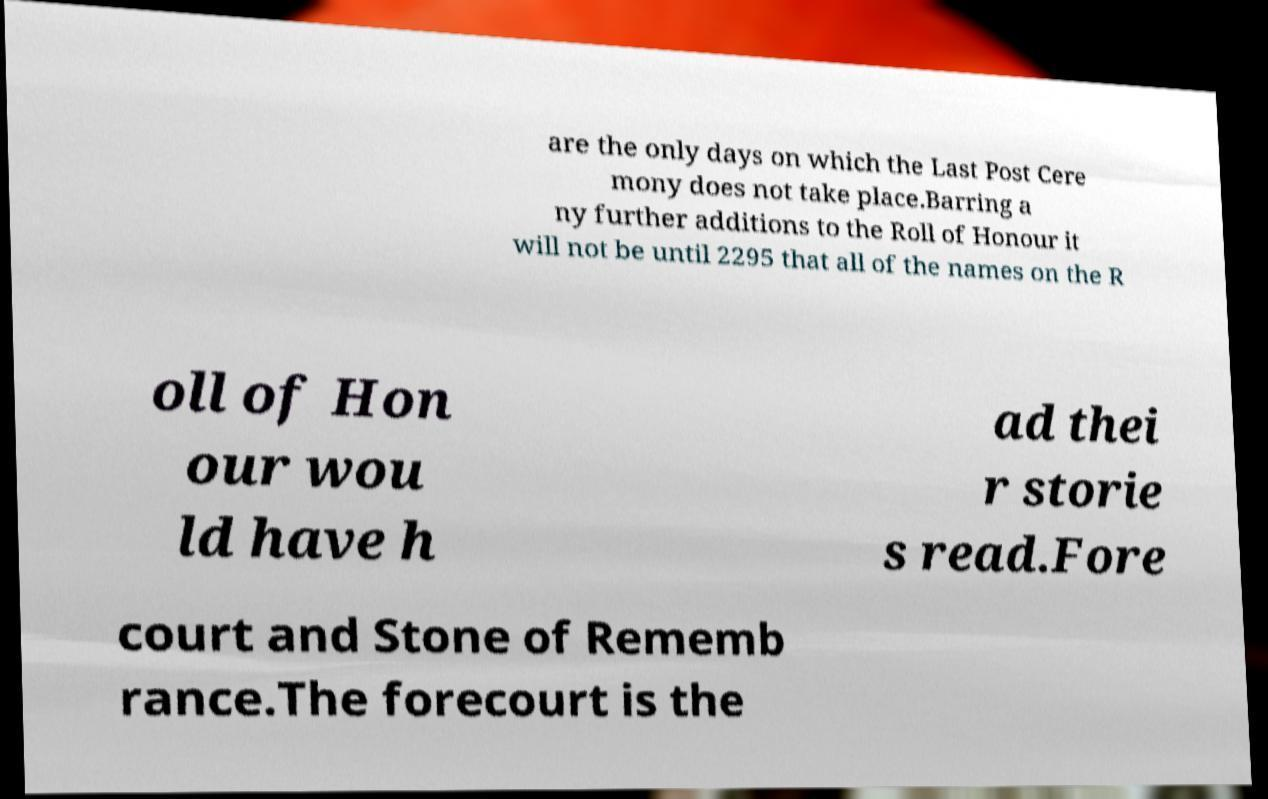Can you accurately transcribe the text from the provided image for me? are the only days on which the Last Post Cere mony does not take place.Barring a ny further additions to the Roll of Honour it will not be until 2295 that all of the names on the R oll of Hon our wou ld have h ad thei r storie s read.Fore court and Stone of Rememb rance.The forecourt is the 